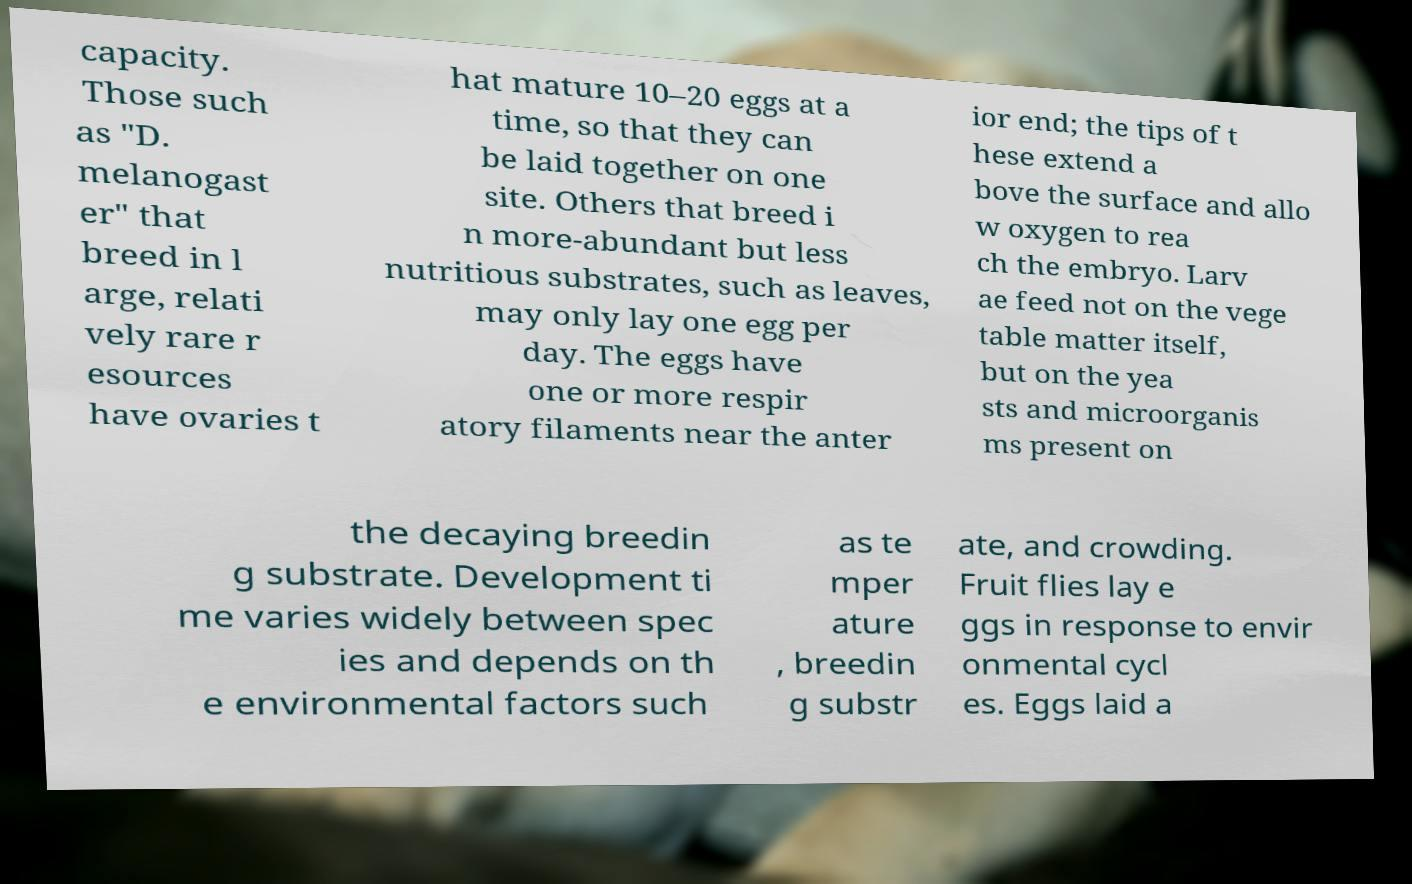Please read and relay the text visible in this image. What does it say? capacity. Those such as "D. melanogast er" that breed in l arge, relati vely rare r esources have ovaries t hat mature 10–20 eggs at a time, so that they can be laid together on one site. Others that breed i n more-abundant but less nutritious substrates, such as leaves, may only lay one egg per day. The eggs have one or more respir atory filaments near the anter ior end; the tips of t hese extend a bove the surface and allo w oxygen to rea ch the embryo. Larv ae feed not on the vege table matter itself, but on the yea sts and microorganis ms present on the decaying breedin g substrate. Development ti me varies widely between spec ies and depends on th e environmental factors such as te mper ature , breedin g substr ate, and crowding. Fruit flies lay e ggs in response to envir onmental cycl es. Eggs laid a 